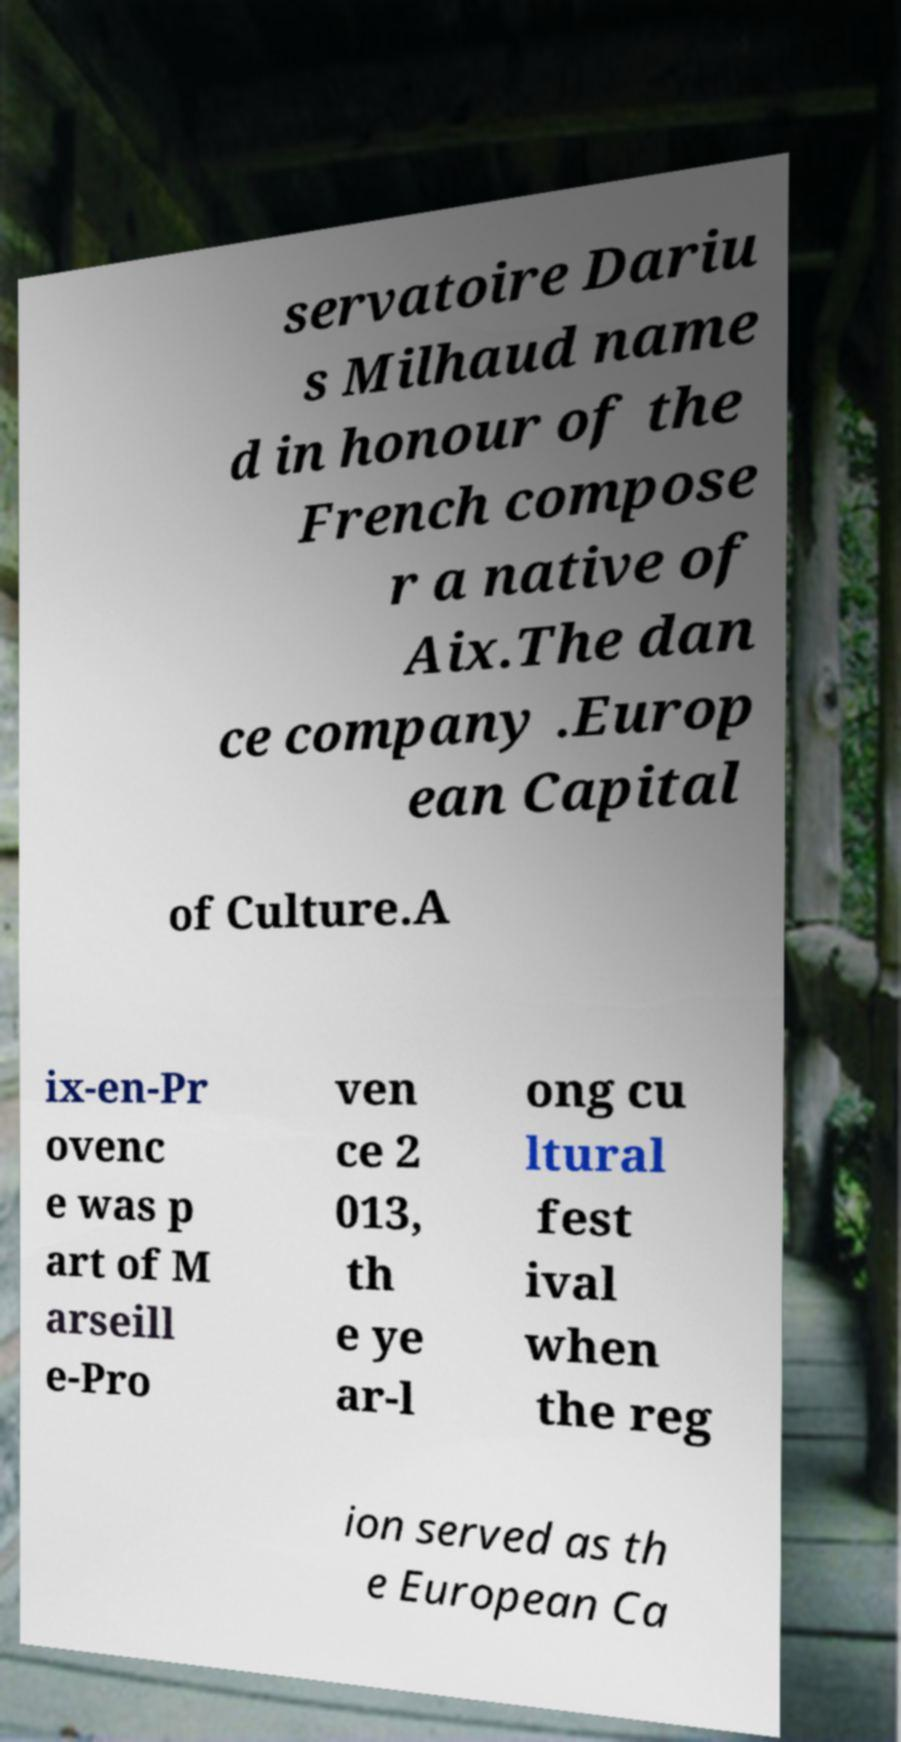Can you read and provide the text displayed in the image?This photo seems to have some interesting text. Can you extract and type it out for me? servatoire Dariu s Milhaud name d in honour of the French compose r a native of Aix.The dan ce company .Europ ean Capital of Culture.A ix-en-Pr ovenc e was p art of M arseill e-Pro ven ce 2 013, th e ye ar-l ong cu ltural fest ival when the reg ion served as th e European Ca 